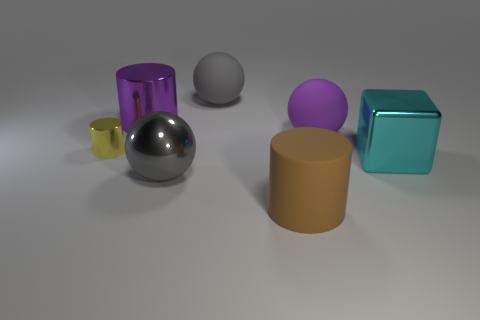What are the textures of the objects in the image? The textures of objects in the image vary: there is a shiny, reflective silver ball and a purple cylinder with a similar shiny surface, suggesting a metallic texture. Two objects, a tan cylinder and a pink sphere, have matte finishes, while the cube appears to have a smooth but less reflective surface compared to the shiny objects. 